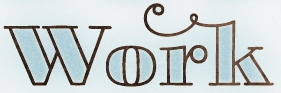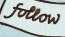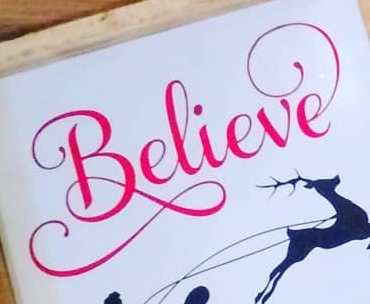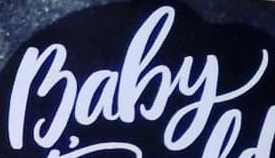What text is displayed in these images sequentially, separated by a semicolon? work; follow; Believe; Baby 